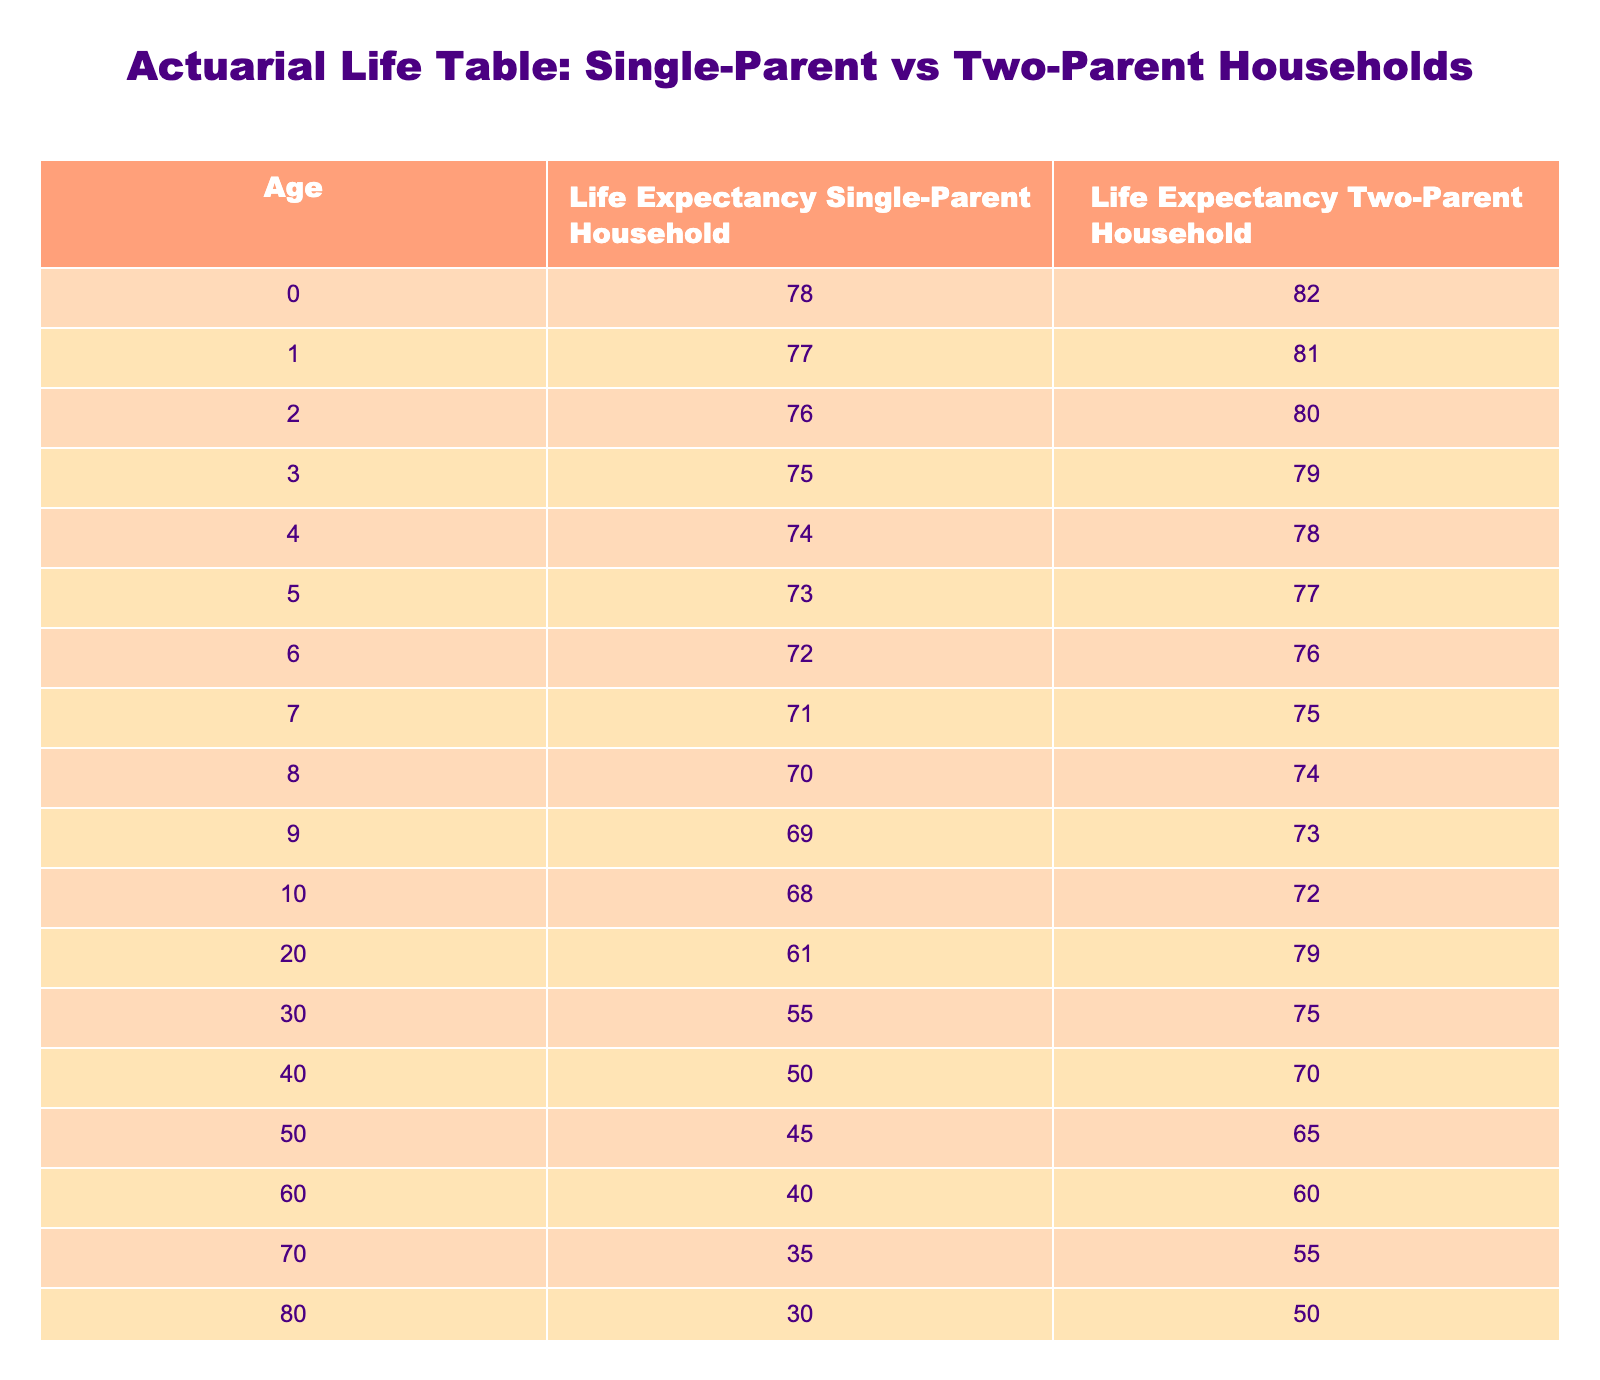What is the life expectancy of a 0-year-old in a single-parent household? According to the table, the life expectancy of a 0-year-old in a single-parent household is given directly under that column. It shows 78 years.
Answer: 78 What is the difference in life expectancy between single-parent households and two-parent households at age 10? For age 10, the life expectancy in a single-parent household is 68 years, while in a two-parent household, it is 72 years. The difference is calculated as 72 - 68 = 4 years.
Answer: 4 Is the life expectancy of a 30-year-old in a two-parent household higher than 70? Checking the table, the life expectancy of a 30-year-old in a two-parent household is 75 years, which is indeed higher than 70.
Answer: Yes What is the average life expectancy of 5-year-olds in single-parent and two-parent households combined? For single-parent households at age 5, it is 73 years, and for two-parent households, it is 77 years. The average is calculated as (73 + 77) / 2 = 75.
Answer: 75 At what age does the life expectancy of single-parent households drop below 40? Looking at the table, the life expectancy for single-parent households reaches 40 at age 60. By age 70, it drops to 35. Therefore, it falls below 40 between those two ages.
Answer: 70 What is the life expectancy of a 40-year-old in a single-parent household? Referring to the table, the life expectancy for a 40-year-old in a single-parent household is 50 years.
Answer: 50 How much longer can a 20-year-old expected to live in a two-parent household compared to a single-parent household? The life expectancy for a 20-year-old in a single-parent household is 61 years, while in a two-parent household, it is 79 years. The difference is 79 - 61 = 18 years.
Answer: 18 Is it true that a child aged 8 in a two-parent household has a life expectancy of at least 75 years? Looking at the table, a child aged 8 in a two-parent household has a life expectancy of 74 years, which is not at least 75.
Answer: No 